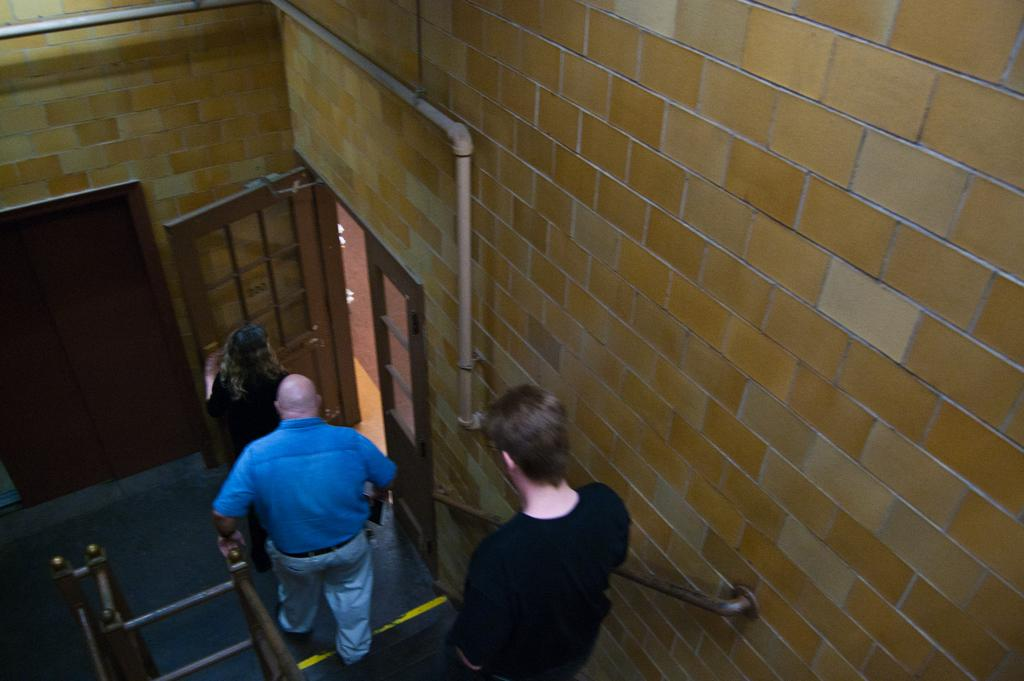How many people are in the image? There are three people in the image. What are the people doing in the image? The people appear to be walking in the image. What structures can be seen in the image? There are poles, a wall, a pipe, and doors visible in the image. What is the surface that the people are walking on in the image? There is a floor visible at the bottom of the image. What type of fruit is being carried by the yoke in the image? There is no fruit or yoke present in the image. Which parent is accompanying the children in the image? There is no reference to children or parents in the image; it features three people walking. 